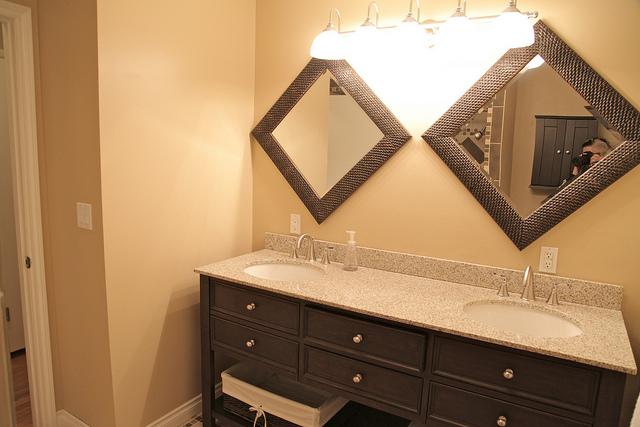How many mirrors are there?
Give a very brief answer. 2. Are the mirrors diamond shaped?
Quick response, please. Yes. What is on the counter?
Quick response, please. Soap. 